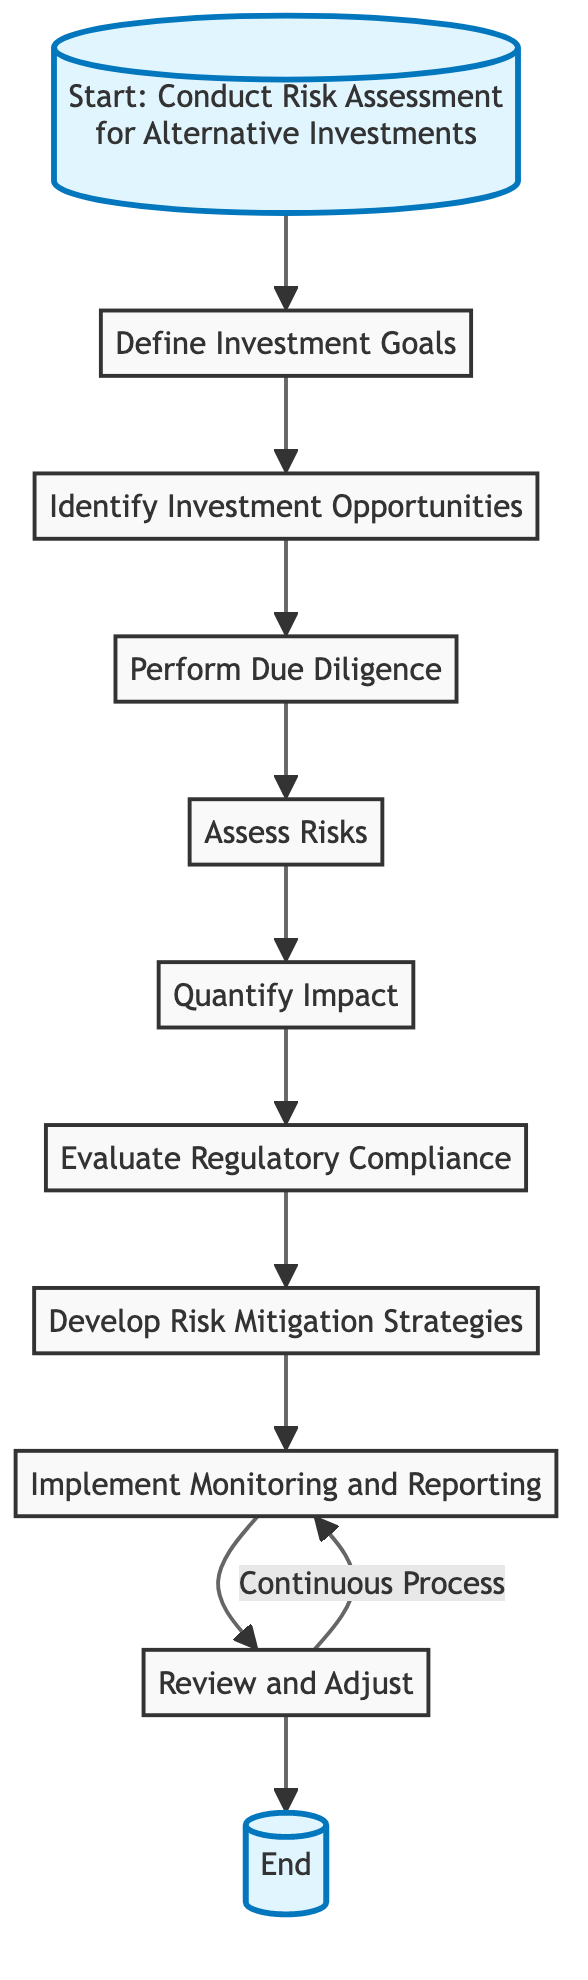What is the first step in the risk assessment process? The diagram starts with the node labeled "Define Investment Goals," which indicates the first step in conducting a risk assessment for alternative investments.
Answer: Define Investment Goals How many steps are there in the risk assessment process? By counting each node from the diagram, there are a total of nine distinct steps in the process outlined for conducting risk assessment for alternative investments.
Answer: Nine Which step comes after "Assess Risks"? Referring to the flowchart, the step directly following "Assess Risks" is "Quantify Impact."
Answer: Quantify Impact What is the final step in the process? The last node in the flowchart indicates the endpoint of the process, which is "End."
Answer: End What are three specific risks assessed in the "Assess Risks" step? The "Assess Risks" step mentions market risk, liquidity risk, and credit risk among the types of risks to evaluate as part of the risk assessment.
Answer: Market risk, liquidity risk, credit risk Which step is a continuous process according to the diagram? The diagram labels "Implement Monitoring and Reporting" as the step that is part of a continuous process, suggesting ongoing assessment and management.
Answer: Implement Monitoring and Reporting What step follows "Evaluate Regulatory Compliance"? The diagram shows "Develop Risk Mitigation Strategies" as the step that follows "Evaluate Regulatory Compliance."
Answer: Develop Risk Mitigation Strategies Why is "Review and Adjust" linked back to "Implement Monitoring and Reporting"? The connection indicates that after reviewing investment performance and strategies, adjustments may lead back to ongoing monitoring, emphasizing a cyclical nature in the assessment process.
Answer: Continuous process What type of analysis is mentioned in the "Perform Due Diligence" step? The "Perform Due Diligence" step in the diagram references conducting thorough analysis on historical performance, highlighting the importance of evaluating performance data.
Answer: Historical performance analysis 